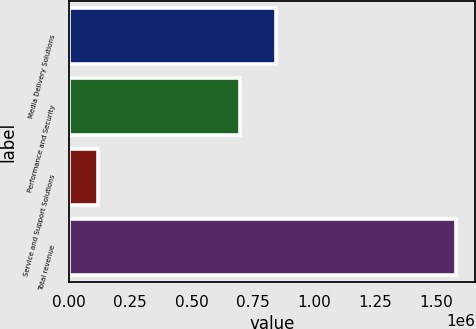<chart> <loc_0><loc_0><loc_500><loc_500><bar_chart><fcel>Media Delivery Solutions<fcel>Performance and Security<fcel>Service and Support Solutions<fcel>Total revenue<nl><fcel>843875<fcel>697825<fcel>117418<fcel>1.57792e+06<nl></chart> 